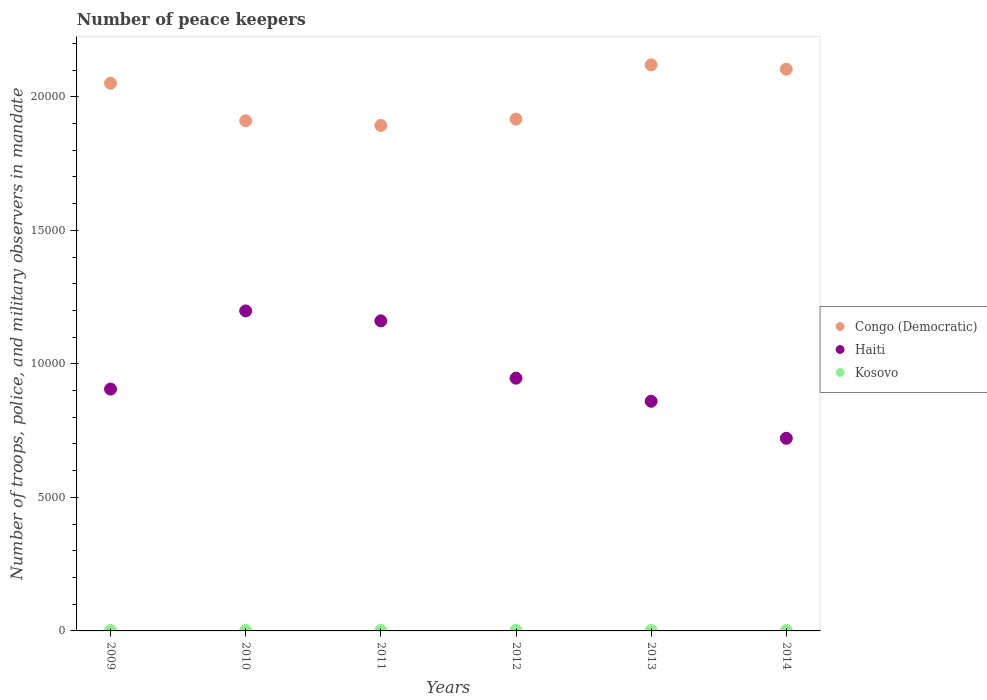How many different coloured dotlines are there?
Keep it short and to the point. 3. What is the number of peace keepers in in Kosovo in 2013?
Give a very brief answer. 14. What is the difference between the number of peace keepers in in Haiti in 2011 and that in 2014?
Give a very brief answer. 4398. What is the difference between the number of peace keepers in in Congo (Democratic) in 2011 and the number of peace keepers in in Haiti in 2009?
Provide a succinct answer. 9871. What is the average number of peace keepers in in Kosovo per year?
Your answer should be very brief. 15.83. In the year 2009, what is the difference between the number of peace keepers in in Congo (Democratic) and number of peace keepers in in Kosovo?
Provide a succinct answer. 2.05e+04. In how many years, is the number of peace keepers in in Haiti greater than 15000?
Make the answer very short. 0. What is the ratio of the number of peace keepers in in Congo (Democratic) in 2013 to that in 2014?
Ensure brevity in your answer.  1.01. Is the number of peace keepers in in Kosovo in 2010 less than that in 2013?
Your answer should be very brief. No. What is the difference between the highest and the second highest number of peace keepers in in Haiti?
Your answer should be very brief. 373. What is the difference between the highest and the lowest number of peace keepers in in Congo (Democratic)?
Give a very brief answer. 2270. In how many years, is the number of peace keepers in in Haiti greater than the average number of peace keepers in in Haiti taken over all years?
Provide a short and direct response. 2. Is the number of peace keepers in in Congo (Democratic) strictly greater than the number of peace keepers in in Kosovo over the years?
Ensure brevity in your answer.  Yes. Is the number of peace keepers in in Kosovo strictly less than the number of peace keepers in in Congo (Democratic) over the years?
Your answer should be compact. Yes. Are the values on the major ticks of Y-axis written in scientific E-notation?
Keep it short and to the point. No. Does the graph contain any zero values?
Offer a very short reply. No. Does the graph contain grids?
Provide a succinct answer. No. Where does the legend appear in the graph?
Provide a succinct answer. Center right. How many legend labels are there?
Give a very brief answer. 3. What is the title of the graph?
Make the answer very short. Number of peace keepers. Does "Thailand" appear as one of the legend labels in the graph?
Make the answer very short. No. What is the label or title of the X-axis?
Make the answer very short. Years. What is the label or title of the Y-axis?
Provide a short and direct response. Number of troops, police, and military observers in mandate. What is the Number of troops, police, and military observers in mandate of Congo (Democratic) in 2009?
Provide a succinct answer. 2.05e+04. What is the Number of troops, police, and military observers in mandate of Haiti in 2009?
Provide a succinct answer. 9057. What is the Number of troops, police, and military observers in mandate in Kosovo in 2009?
Your answer should be very brief. 17. What is the Number of troops, police, and military observers in mandate in Congo (Democratic) in 2010?
Ensure brevity in your answer.  1.91e+04. What is the Number of troops, police, and military observers in mandate of Haiti in 2010?
Offer a very short reply. 1.20e+04. What is the Number of troops, police, and military observers in mandate of Kosovo in 2010?
Your response must be concise. 16. What is the Number of troops, police, and military observers in mandate in Congo (Democratic) in 2011?
Make the answer very short. 1.89e+04. What is the Number of troops, police, and military observers in mandate in Haiti in 2011?
Your response must be concise. 1.16e+04. What is the Number of troops, police, and military observers in mandate of Kosovo in 2011?
Provide a short and direct response. 16. What is the Number of troops, police, and military observers in mandate of Congo (Democratic) in 2012?
Offer a very short reply. 1.92e+04. What is the Number of troops, police, and military observers in mandate in Haiti in 2012?
Provide a short and direct response. 9464. What is the Number of troops, police, and military observers in mandate in Congo (Democratic) in 2013?
Give a very brief answer. 2.12e+04. What is the Number of troops, police, and military observers in mandate in Haiti in 2013?
Keep it short and to the point. 8600. What is the Number of troops, police, and military observers in mandate in Kosovo in 2013?
Provide a succinct answer. 14. What is the Number of troops, police, and military observers in mandate in Congo (Democratic) in 2014?
Make the answer very short. 2.10e+04. What is the Number of troops, police, and military observers in mandate in Haiti in 2014?
Offer a very short reply. 7213. Across all years, what is the maximum Number of troops, police, and military observers in mandate of Congo (Democratic)?
Make the answer very short. 2.12e+04. Across all years, what is the maximum Number of troops, police, and military observers in mandate in Haiti?
Your answer should be very brief. 1.20e+04. Across all years, what is the maximum Number of troops, police, and military observers in mandate of Kosovo?
Keep it short and to the point. 17. Across all years, what is the minimum Number of troops, police, and military observers in mandate of Congo (Democratic)?
Provide a succinct answer. 1.89e+04. Across all years, what is the minimum Number of troops, police, and military observers in mandate of Haiti?
Ensure brevity in your answer.  7213. Across all years, what is the minimum Number of troops, police, and military observers in mandate in Kosovo?
Your answer should be compact. 14. What is the total Number of troops, police, and military observers in mandate in Congo (Democratic) in the graph?
Your answer should be very brief. 1.20e+05. What is the total Number of troops, police, and military observers in mandate in Haiti in the graph?
Your answer should be compact. 5.79e+04. What is the difference between the Number of troops, police, and military observers in mandate of Congo (Democratic) in 2009 and that in 2010?
Make the answer very short. 1404. What is the difference between the Number of troops, police, and military observers in mandate in Haiti in 2009 and that in 2010?
Your response must be concise. -2927. What is the difference between the Number of troops, police, and military observers in mandate of Congo (Democratic) in 2009 and that in 2011?
Make the answer very short. 1581. What is the difference between the Number of troops, police, and military observers in mandate of Haiti in 2009 and that in 2011?
Provide a succinct answer. -2554. What is the difference between the Number of troops, police, and military observers in mandate of Congo (Democratic) in 2009 and that in 2012?
Give a very brief answer. 1343. What is the difference between the Number of troops, police, and military observers in mandate of Haiti in 2009 and that in 2012?
Keep it short and to the point. -407. What is the difference between the Number of troops, police, and military observers in mandate in Kosovo in 2009 and that in 2012?
Provide a succinct answer. 1. What is the difference between the Number of troops, police, and military observers in mandate in Congo (Democratic) in 2009 and that in 2013?
Your answer should be compact. -689. What is the difference between the Number of troops, police, and military observers in mandate of Haiti in 2009 and that in 2013?
Your answer should be compact. 457. What is the difference between the Number of troops, police, and military observers in mandate of Kosovo in 2009 and that in 2013?
Your response must be concise. 3. What is the difference between the Number of troops, police, and military observers in mandate of Congo (Democratic) in 2009 and that in 2014?
Give a very brief answer. -527. What is the difference between the Number of troops, police, and military observers in mandate in Haiti in 2009 and that in 2014?
Provide a succinct answer. 1844. What is the difference between the Number of troops, police, and military observers in mandate of Kosovo in 2009 and that in 2014?
Your response must be concise. 1. What is the difference between the Number of troops, police, and military observers in mandate in Congo (Democratic) in 2010 and that in 2011?
Make the answer very short. 177. What is the difference between the Number of troops, police, and military observers in mandate in Haiti in 2010 and that in 2011?
Keep it short and to the point. 373. What is the difference between the Number of troops, police, and military observers in mandate of Kosovo in 2010 and that in 2011?
Provide a succinct answer. 0. What is the difference between the Number of troops, police, and military observers in mandate in Congo (Democratic) in 2010 and that in 2012?
Your answer should be compact. -61. What is the difference between the Number of troops, police, and military observers in mandate of Haiti in 2010 and that in 2012?
Offer a terse response. 2520. What is the difference between the Number of troops, police, and military observers in mandate of Kosovo in 2010 and that in 2012?
Keep it short and to the point. 0. What is the difference between the Number of troops, police, and military observers in mandate of Congo (Democratic) in 2010 and that in 2013?
Provide a short and direct response. -2093. What is the difference between the Number of troops, police, and military observers in mandate in Haiti in 2010 and that in 2013?
Provide a short and direct response. 3384. What is the difference between the Number of troops, police, and military observers in mandate in Kosovo in 2010 and that in 2013?
Ensure brevity in your answer.  2. What is the difference between the Number of troops, police, and military observers in mandate in Congo (Democratic) in 2010 and that in 2014?
Your response must be concise. -1931. What is the difference between the Number of troops, police, and military observers in mandate of Haiti in 2010 and that in 2014?
Make the answer very short. 4771. What is the difference between the Number of troops, police, and military observers in mandate of Congo (Democratic) in 2011 and that in 2012?
Offer a very short reply. -238. What is the difference between the Number of troops, police, and military observers in mandate in Haiti in 2011 and that in 2012?
Make the answer very short. 2147. What is the difference between the Number of troops, police, and military observers in mandate in Congo (Democratic) in 2011 and that in 2013?
Your answer should be very brief. -2270. What is the difference between the Number of troops, police, and military observers in mandate of Haiti in 2011 and that in 2013?
Your response must be concise. 3011. What is the difference between the Number of troops, police, and military observers in mandate of Kosovo in 2011 and that in 2013?
Your response must be concise. 2. What is the difference between the Number of troops, police, and military observers in mandate in Congo (Democratic) in 2011 and that in 2014?
Give a very brief answer. -2108. What is the difference between the Number of troops, police, and military observers in mandate of Haiti in 2011 and that in 2014?
Offer a very short reply. 4398. What is the difference between the Number of troops, police, and military observers in mandate of Kosovo in 2011 and that in 2014?
Provide a short and direct response. 0. What is the difference between the Number of troops, police, and military observers in mandate of Congo (Democratic) in 2012 and that in 2013?
Give a very brief answer. -2032. What is the difference between the Number of troops, police, and military observers in mandate of Haiti in 2012 and that in 2013?
Your response must be concise. 864. What is the difference between the Number of troops, police, and military observers in mandate of Kosovo in 2012 and that in 2013?
Offer a very short reply. 2. What is the difference between the Number of troops, police, and military observers in mandate of Congo (Democratic) in 2012 and that in 2014?
Keep it short and to the point. -1870. What is the difference between the Number of troops, police, and military observers in mandate in Haiti in 2012 and that in 2014?
Provide a short and direct response. 2251. What is the difference between the Number of troops, police, and military observers in mandate in Kosovo in 2012 and that in 2014?
Give a very brief answer. 0. What is the difference between the Number of troops, police, and military observers in mandate in Congo (Democratic) in 2013 and that in 2014?
Offer a terse response. 162. What is the difference between the Number of troops, police, and military observers in mandate in Haiti in 2013 and that in 2014?
Your response must be concise. 1387. What is the difference between the Number of troops, police, and military observers in mandate of Kosovo in 2013 and that in 2014?
Your response must be concise. -2. What is the difference between the Number of troops, police, and military observers in mandate of Congo (Democratic) in 2009 and the Number of troops, police, and military observers in mandate of Haiti in 2010?
Give a very brief answer. 8525. What is the difference between the Number of troops, police, and military observers in mandate in Congo (Democratic) in 2009 and the Number of troops, police, and military observers in mandate in Kosovo in 2010?
Keep it short and to the point. 2.05e+04. What is the difference between the Number of troops, police, and military observers in mandate of Haiti in 2009 and the Number of troops, police, and military observers in mandate of Kosovo in 2010?
Offer a terse response. 9041. What is the difference between the Number of troops, police, and military observers in mandate of Congo (Democratic) in 2009 and the Number of troops, police, and military observers in mandate of Haiti in 2011?
Make the answer very short. 8898. What is the difference between the Number of troops, police, and military observers in mandate in Congo (Democratic) in 2009 and the Number of troops, police, and military observers in mandate in Kosovo in 2011?
Offer a very short reply. 2.05e+04. What is the difference between the Number of troops, police, and military observers in mandate of Haiti in 2009 and the Number of troops, police, and military observers in mandate of Kosovo in 2011?
Keep it short and to the point. 9041. What is the difference between the Number of troops, police, and military observers in mandate of Congo (Democratic) in 2009 and the Number of troops, police, and military observers in mandate of Haiti in 2012?
Ensure brevity in your answer.  1.10e+04. What is the difference between the Number of troops, police, and military observers in mandate of Congo (Democratic) in 2009 and the Number of troops, police, and military observers in mandate of Kosovo in 2012?
Provide a succinct answer. 2.05e+04. What is the difference between the Number of troops, police, and military observers in mandate in Haiti in 2009 and the Number of troops, police, and military observers in mandate in Kosovo in 2012?
Provide a succinct answer. 9041. What is the difference between the Number of troops, police, and military observers in mandate in Congo (Democratic) in 2009 and the Number of troops, police, and military observers in mandate in Haiti in 2013?
Provide a succinct answer. 1.19e+04. What is the difference between the Number of troops, police, and military observers in mandate in Congo (Democratic) in 2009 and the Number of troops, police, and military observers in mandate in Kosovo in 2013?
Keep it short and to the point. 2.05e+04. What is the difference between the Number of troops, police, and military observers in mandate in Haiti in 2009 and the Number of troops, police, and military observers in mandate in Kosovo in 2013?
Make the answer very short. 9043. What is the difference between the Number of troops, police, and military observers in mandate of Congo (Democratic) in 2009 and the Number of troops, police, and military observers in mandate of Haiti in 2014?
Keep it short and to the point. 1.33e+04. What is the difference between the Number of troops, police, and military observers in mandate of Congo (Democratic) in 2009 and the Number of troops, police, and military observers in mandate of Kosovo in 2014?
Ensure brevity in your answer.  2.05e+04. What is the difference between the Number of troops, police, and military observers in mandate in Haiti in 2009 and the Number of troops, police, and military observers in mandate in Kosovo in 2014?
Your answer should be very brief. 9041. What is the difference between the Number of troops, police, and military observers in mandate in Congo (Democratic) in 2010 and the Number of troops, police, and military observers in mandate in Haiti in 2011?
Ensure brevity in your answer.  7494. What is the difference between the Number of troops, police, and military observers in mandate of Congo (Democratic) in 2010 and the Number of troops, police, and military observers in mandate of Kosovo in 2011?
Offer a terse response. 1.91e+04. What is the difference between the Number of troops, police, and military observers in mandate in Haiti in 2010 and the Number of troops, police, and military observers in mandate in Kosovo in 2011?
Offer a terse response. 1.20e+04. What is the difference between the Number of troops, police, and military observers in mandate in Congo (Democratic) in 2010 and the Number of troops, police, and military observers in mandate in Haiti in 2012?
Provide a succinct answer. 9641. What is the difference between the Number of troops, police, and military observers in mandate of Congo (Democratic) in 2010 and the Number of troops, police, and military observers in mandate of Kosovo in 2012?
Your response must be concise. 1.91e+04. What is the difference between the Number of troops, police, and military observers in mandate in Haiti in 2010 and the Number of troops, police, and military observers in mandate in Kosovo in 2012?
Ensure brevity in your answer.  1.20e+04. What is the difference between the Number of troops, police, and military observers in mandate of Congo (Democratic) in 2010 and the Number of troops, police, and military observers in mandate of Haiti in 2013?
Give a very brief answer. 1.05e+04. What is the difference between the Number of troops, police, and military observers in mandate of Congo (Democratic) in 2010 and the Number of troops, police, and military observers in mandate of Kosovo in 2013?
Provide a short and direct response. 1.91e+04. What is the difference between the Number of troops, police, and military observers in mandate of Haiti in 2010 and the Number of troops, police, and military observers in mandate of Kosovo in 2013?
Provide a succinct answer. 1.20e+04. What is the difference between the Number of troops, police, and military observers in mandate in Congo (Democratic) in 2010 and the Number of troops, police, and military observers in mandate in Haiti in 2014?
Your answer should be compact. 1.19e+04. What is the difference between the Number of troops, police, and military observers in mandate of Congo (Democratic) in 2010 and the Number of troops, police, and military observers in mandate of Kosovo in 2014?
Offer a very short reply. 1.91e+04. What is the difference between the Number of troops, police, and military observers in mandate of Haiti in 2010 and the Number of troops, police, and military observers in mandate of Kosovo in 2014?
Give a very brief answer. 1.20e+04. What is the difference between the Number of troops, police, and military observers in mandate of Congo (Democratic) in 2011 and the Number of troops, police, and military observers in mandate of Haiti in 2012?
Your answer should be compact. 9464. What is the difference between the Number of troops, police, and military observers in mandate of Congo (Democratic) in 2011 and the Number of troops, police, and military observers in mandate of Kosovo in 2012?
Offer a terse response. 1.89e+04. What is the difference between the Number of troops, police, and military observers in mandate of Haiti in 2011 and the Number of troops, police, and military observers in mandate of Kosovo in 2012?
Provide a succinct answer. 1.16e+04. What is the difference between the Number of troops, police, and military observers in mandate in Congo (Democratic) in 2011 and the Number of troops, police, and military observers in mandate in Haiti in 2013?
Your answer should be compact. 1.03e+04. What is the difference between the Number of troops, police, and military observers in mandate of Congo (Democratic) in 2011 and the Number of troops, police, and military observers in mandate of Kosovo in 2013?
Your response must be concise. 1.89e+04. What is the difference between the Number of troops, police, and military observers in mandate in Haiti in 2011 and the Number of troops, police, and military observers in mandate in Kosovo in 2013?
Provide a succinct answer. 1.16e+04. What is the difference between the Number of troops, police, and military observers in mandate of Congo (Democratic) in 2011 and the Number of troops, police, and military observers in mandate of Haiti in 2014?
Your response must be concise. 1.17e+04. What is the difference between the Number of troops, police, and military observers in mandate in Congo (Democratic) in 2011 and the Number of troops, police, and military observers in mandate in Kosovo in 2014?
Your answer should be compact. 1.89e+04. What is the difference between the Number of troops, police, and military observers in mandate in Haiti in 2011 and the Number of troops, police, and military observers in mandate in Kosovo in 2014?
Ensure brevity in your answer.  1.16e+04. What is the difference between the Number of troops, police, and military observers in mandate in Congo (Democratic) in 2012 and the Number of troops, police, and military observers in mandate in Haiti in 2013?
Your answer should be compact. 1.06e+04. What is the difference between the Number of troops, police, and military observers in mandate of Congo (Democratic) in 2012 and the Number of troops, police, and military observers in mandate of Kosovo in 2013?
Offer a very short reply. 1.92e+04. What is the difference between the Number of troops, police, and military observers in mandate in Haiti in 2012 and the Number of troops, police, and military observers in mandate in Kosovo in 2013?
Provide a succinct answer. 9450. What is the difference between the Number of troops, police, and military observers in mandate of Congo (Democratic) in 2012 and the Number of troops, police, and military observers in mandate of Haiti in 2014?
Make the answer very short. 1.20e+04. What is the difference between the Number of troops, police, and military observers in mandate of Congo (Democratic) in 2012 and the Number of troops, police, and military observers in mandate of Kosovo in 2014?
Make the answer very short. 1.92e+04. What is the difference between the Number of troops, police, and military observers in mandate of Haiti in 2012 and the Number of troops, police, and military observers in mandate of Kosovo in 2014?
Your answer should be very brief. 9448. What is the difference between the Number of troops, police, and military observers in mandate in Congo (Democratic) in 2013 and the Number of troops, police, and military observers in mandate in Haiti in 2014?
Provide a short and direct response. 1.40e+04. What is the difference between the Number of troops, police, and military observers in mandate of Congo (Democratic) in 2013 and the Number of troops, police, and military observers in mandate of Kosovo in 2014?
Your answer should be very brief. 2.12e+04. What is the difference between the Number of troops, police, and military observers in mandate of Haiti in 2013 and the Number of troops, police, and military observers in mandate of Kosovo in 2014?
Your response must be concise. 8584. What is the average Number of troops, police, and military observers in mandate in Congo (Democratic) per year?
Ensure brevity in your answer.  2.00e+04. What is the average Number of troops, police, and military observers in mandate in Haiti per year?
Keep it short and to the point. 9654.83. What is the average Number of troops, police, and military observers in mandate in Kosovo per year?
Ensure brevity in your answer.  15.83. In the year 2009, what is the difference between the Number of troops, police, and military observers in mandate in Congo (Democratic) and Number of troops, police, and military observers in mandate in Haiti?
Your answer should be very brief. 1.15e+04. In the year 2009, what is the difference between the Number of troops, police, and military observers in mandate of Congo (Democratic) and Number of troops, police, and military observers in mandate of Kosovo?
Ensure brevity in your answer.  2.05e+04. In the year 2009, what is the difference between the Number of troops, police, and military observers in mandate in Haiti and Number of troops, police, and military observers in mandate in Kosovo?
Your answer should be compact. 9040. In the year 2010, what is the difference between the Number of troops, police, and military observers in mandate of Congo (Democratic) and Number of troops, police, and military observers in mandate of Haiti?
Offer a terse response. 7121. In the year 2010, what is the difference between the Number of troops, police, and military observers in mandate of Congo (Democratic) and Number of troops, police, and military observers in mandate of Kosovo?
Keep it short and to the point. 1.91e+04. In the year 2010, what is the difference between the Number of troops, police, and military observers in mandate in Haiti and Number of troops, police, and military observers in mandate in Kosovo?
Provide a succinct answer. 1.20e+04. In the year 2011, what is the difference between the Number of troops, police, and military observers in mandate of Congo (Democratic) and Number of troops, police, and military observers in mandate of Haiti?
Your answer should be very brief. 7317. In the year 2011, what is the difference between the Number of troops, police, and military observers in mandate in Congo (Democratic) and Number of troops, police, and military observers in mandate in Kosovo?
Your response must be concise. 1.89e+04. In the year 2011, what is the difference between the Number of troops, police, and military observers in mandate of Haiti and Number of troops, police, and military observers in mandate of Kosovo?
Provide a short and direct response. 1.16e+04. In the year 2012, what is the difference between the Number of troops, police, and military observers in mandate in Congo (Democratic) and Number of troops, police, and military observers in mandate in Haiti?
Make the answer very short. 9702. In the year 2012, what is the difference between the Number of troops, police, and military observers in mandate of Congo (Democratic) and Number of troops, police, and military observers in mandate of Kosovo?
Keep it short and to the point. 1.92e+04. In the year 2012, what is the difference between the Number of troops, police, and military observers in mandate in Haiti and Number of troops, police, and military observers in mandate in Kosovo?
Keep it short and to the point. 9448. In the year 2013, what is the difference between the Number of troops, police, and military observers in mandate of Congo (Democratic) and Number of troops, police, and military observers in mandate of Haiti?
Your answer should be very brief. 1.26e+04. In the year 2013, what is the difference between the Number of troops, police, and military observers in mandate in Congo (Democratic) and Number of troops, police, and military observers in mandate in Kosovo?
Keep it short and to the point. 2.12e+04. In the year 2013, what is the difference between the Number of troops, police, and military observers in mandate in Haiti and Number of troops, police, and military observers in mandate in Kosovo?
Make the answer very short. 8586. In the year 2014, what is the difference between the Number of troops, police, and military observers in mandate in Congo (Democratic) and Number of troops, police, and military observers in mandate in Haiti?
Keep it short and to the point. 1.38e+04. In the year 2014, what is the difference between the Number of troops, police, and military observers in mandate in Congo (Democratic) and Number of troops, police, and military observers in mandate in Kosovo?
Make the answer very short. 2.10e+04. In the year 2014, what is the difference between the Number of troops, police, and military observers in mandate in Haiti and Number of troops, police, and military observers in mandate in Kosovo?
Make the answer very short. 7197. What is the ratio of the Number of troops, police, and military observers in mandate in Congo (Democratic) in 2009 to that in 2010?
Offer a very short reply. 1.07. What is the ratio of the Number of troops, police, and military observers in mandate of Haiti in 2009 to that in 2010?
Ensure brevity in your answer.  0.76. What is the ratio of the Number of troops, police, and military observers in mandate in Congo (Democratic) in 2009 to that in 2011?
Keep it short and to the point. 1.08. What is the ratio of the Number of troops, police, and military observers in mandate in Haiti in 2009 to that in 2011?
Keep it short and to the point. 0.78. What is the ratio of the Number of troops, police, and military observers in mandate in Kosovo in 2009 to that in 2011?
Make the answer very short. 1.06. What is the ratio of the Number of troops, police, and military observers in mandate of Congo (Democratic) in 2009 to that in 2012?
Give a very brief answer. 1.07. What is the ratio of the Number of troops, police, and military observers in mandate of Haiti in 2009 to that in 2012?
Ensure brevity in your answer.  0.96. What is the ratio of the Number of troops, police, and military observers in mandate in Kosovo in 2009 to that in 2012?
Offer a terse response. 1.06. What is the ratio of the Number of troops, police, and military observers in mandate in Congo (Democratic) in 2009 to that in 2013?
Your response must be concise. 0.97. What is the ratio of the Number of troops, police, and military observers in mandate of Haiti in 2009 to that in 2013?
Offer a terse response. 1.05. What is the ratio of the Number of troops, police, and military observers in mandate in Kosovo in 2009 to that in 2013?
Your answer should be compact. 1.21. What is the ratio of the Number of troops, police, and military observers in mandate in Congo (Democratic) in 2009 to that in 2014?
Keep it short and to the point. 0.97. What is the ratio of the Number of troops, police, and military observers in mandate of Haiti in 2009 to that in 2014?
Your answer should be very brief. 1.26. What is the ratio of the Number of troops, police, and military observers in mandate of Congo (Democratic) in 2010 to that in 2011?
Ensure brevity in your answer.  1.01. What is the ratio of the Number of troops, police, and military observers in mandate of Haiti in 2010 to that in 2011?
Make the answer very short. 1.03. What is the ratio of the Number of troops, police, and military observers in mandate of Kosovo in 2010 to that in 2011?
Offer a very short reply. 1. What is the ratio of the Number of troops, police, and military observers in mandate in Congo (Democratic) in 2010 to that in 2012?
Provide a succinct answer. 1. What is the ratio of the Number of troops, police, and military observers in mandate in Haiti in 2010 to that in 2012?
Make the answer very short. 1.27. What is the ratio of the Number of troops, police, and military observers in mandate of Kosovo in 2010 to that in 2012?
Ensure brevity in your answer.  1. What is the ratio of the Number of troops, police, and military observers in mandate of Congo (Democratic) in 2010 to that in 2013?
Offer a very short reply. 0.9. What is the ratio of the Number of troops, police, and military observers in mandate in Haiti in 2010 to that in 2013?
Offer a terse response. 1.39. What is the ratio of the Number of troops, police, and military observers in mandate in Kosovo in 2010 to that in 2013?
Keep it short and to the point. 1.14. What is the ratio of the Number of troops, police, and military observers in mandate in Congo (Democratic) in 2010 to that in 2014?
Make the answer very short. 0.91. What is the ratio of the Number of troops, police, and military observers in mandate of Haiti in 2010 to that in 2014?
Offer a terse response. 1.66. What is the ratio of the Number of troops, police, and military observers in mandate in Congo (Democratic) in 2011 to that in 2012?
Offer a terse response. 0.99. What is the ratio of the Number of troops, police, and military observers in mandate of Haiti in 2011 to that in 2012?
Provide a succinct answer. 1.23. What is the ratio of the Number of troops, police, and military observers in mandate of Kosovo in 2011 to that in 2012?
Provide a succinct answer. 1. What is the ratio of the Number of troops, police, and military observers in mandate of Congo (Democratic) in 2011 to that in 2013?
Ensure brevity in your answer.  0.89. What is the ratio of the Number of troops, police, and military observers in mandate of Haiti in 2011 to that in 2013?
Offer a terse response. 1.35. What is the ratio of the Number of troops, police, and military observers in mandate in Kosovo in 2011 to that in 2013?
Keep it short and to the point. 1.14. What is the ratio of the Number of troops, police, and military observers in mandate of Congo (Democratic) in 2011 to that in 2014?
Your answer should be compact. 0.9. What is the ratio of the Number of troops, police, and military observers in mandate of Haiti in 2011 to that in 2014?
Keep it short and to the point. 1.61. What is the ratio of the Number of troops, police, and military observers in mandate in Congo (Democratic) in 2012 to that in 2013?
Your answer should be very brief. 0.9. What is the ratio of the Number of troops, police, and military observers in mandate of Haiti in 2012 to that in 2013?
Your answer should be very brief. 1.1. What is the ratio of the Number of troops, police, and military observers in mandate in Congo (Democratic) in 2012 to that in 2014?
Ensure brevity in your answer.  0.91. What is the ratio of the Number of troops, police, and military observers in mandate of Haiti in 2012 to that in 2014?
Make the answer very short. 1.31. What is the ratio of the Number of troops, police, and military observers in mandate of Kosovo in 2012 to that in 2014?
Ensure brevity in your answer.  1. What is the ratio of the Number of troops, police, and military observers in mandate in Congo (Democratic) in 2013 to that in 2014?
Offer a very short reply. 1.01. What is the ratio of the Number of troops, police, and military observers in mandate in Haiti in 2013 to that in 2014?
Provide a short and direct response. 1.19. What is the ratio of the Number of troops, police, and military observers in mandate of Kosovo in 2013 to that in 2014?
Provide a succinct answer. 0.88. What is the difference between the highest and the second highest Number of troops, police, and military observers in mandate of Congo (Democratic)?
Offer a terse response. 162. What is the difference between the highest and the second highest Number of troops, police, and military observers in mandate in Haiti?
Keep it short and to the point. 373. What is the difference between the highest and the second highest Number of troops, police, and military observers in mandate in Kosovo?
Provide a succinct answer. 1. What is the difference between the highest and the lowest Number of troops, police, and military observers in mandate of Congo (Democratic)?
Offer a very short reply. 2270. What is the difference between the highest and the lowest Number of troops, police, and military observers in mandate in Haiti?
Provide a short and direct response. 4771. What is the difference between the highest and the lowest Number of troops, police, and military observers in mandate in Kosovo?
Your answer should be compact. 3. 